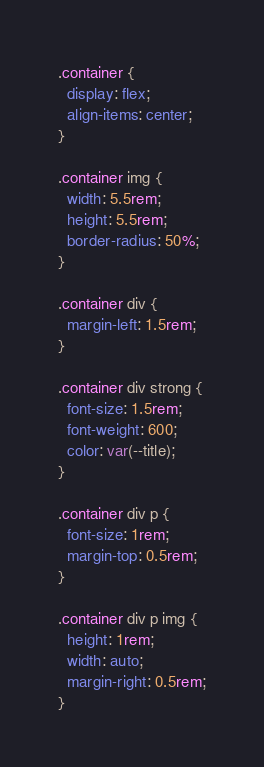<code> <loc_0><loc_0><loc_500><loc_500><_CSS_>.container {
  display: flex;
  align-items: center;
}

.container img {
  width: 5.5rem;
  height: 5.5rem;
  border-radius: 50%;
}

.container div {
  margin-left: 1.5rem;
}

.container div strong {
  font-size: 1.5rem;
  font-weight: 600;
  color: var(--title);
}

.container div p {
  font-size: 1rem;
  margin-top: 0.5rem;
}

.container div p img {
  height: 1rem;
  width: auto;
  margin-right: 0.5rem;
}</code> 